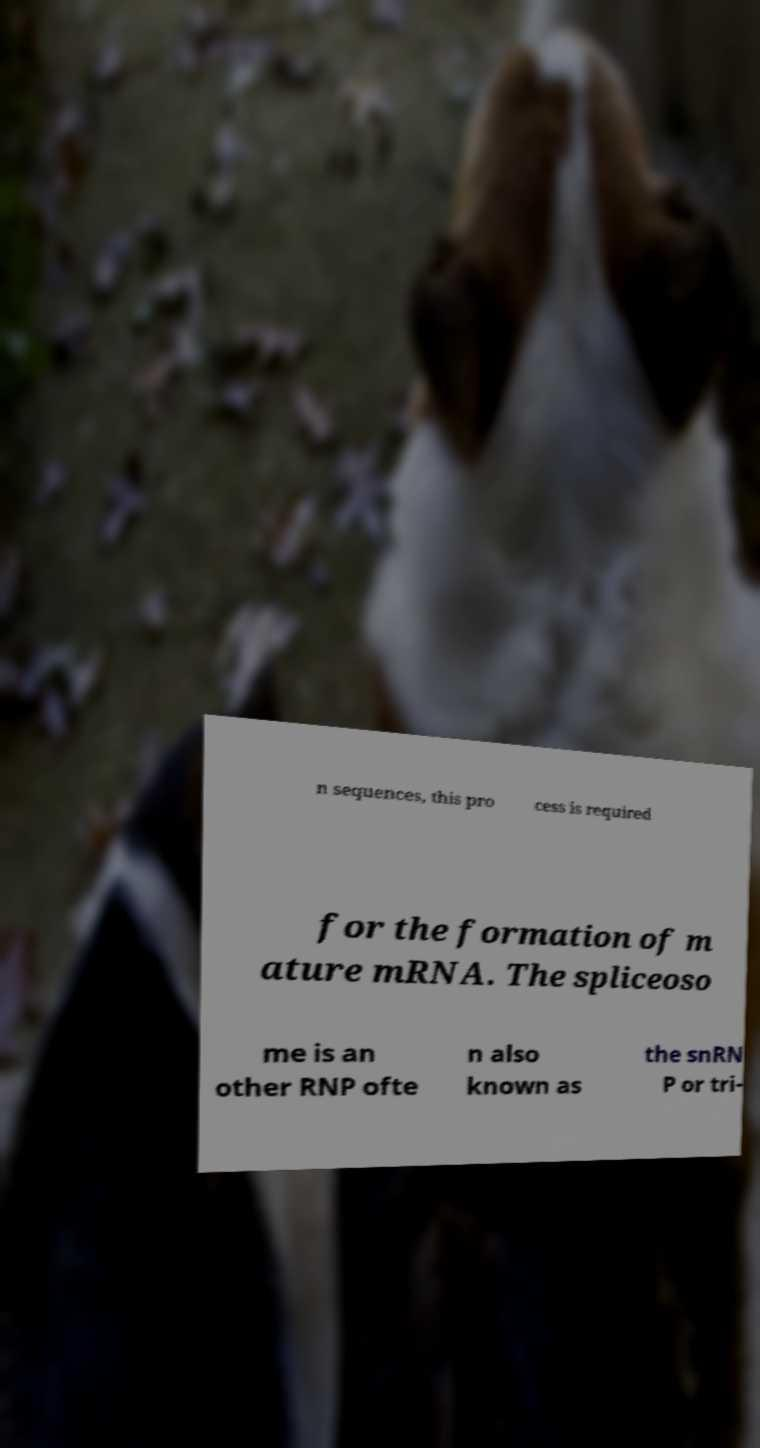Could you assist in decoding the text presented in this image and type it out clearly? n sequences, this pro cess is required for the formation of m ature mRNA. The spliceoso me is an other RNP ofte n also known as the snRN P or tri- 